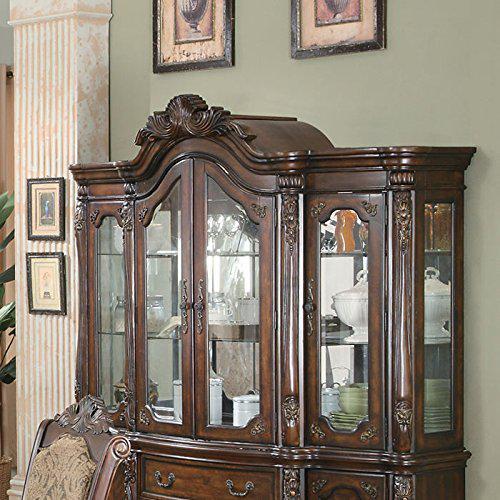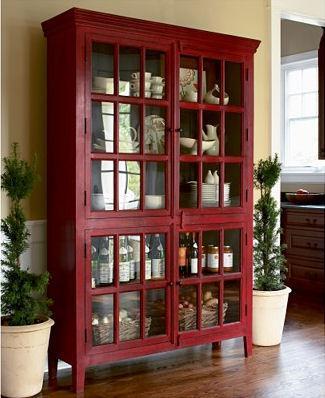The first image is the image on the left, the second image is the image on the right. For the images displayed, is the sentence "One of the wooden cabinets is not flat across the top." factually correct? Answer yes or no. Yes. The first image is the image on the left, the second image is the image on the right. Given the left and right images, does the statement "One of the cabinets is dark wood with four glass doors and a non-flat top." hold true? Answer yes or no. Yes. The first image is the image on the left, the second image is the image on the right. For the images shown, is this caption "There is one picture frame in the image on the right." true? Answer yes or no. No. The first image is the image on the left, the second image is the image on the right. Examine the images to the left and right. Is the description "There is a floor plant near a hutch in one of the images." accurate? Answer yes or no. Yes. 